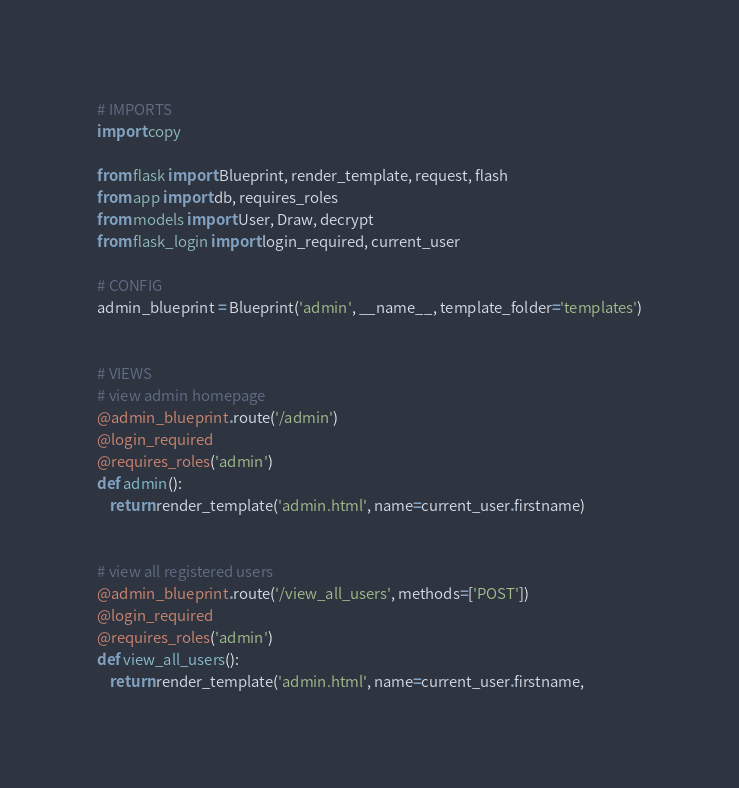Convert code to text. <code><loc_0><loc_0><loc_500><loc_500><_Python_># IMPORTS
import copy

from flask import Blueprint, render_template, request, flash
from app import db, requires_roles
from models import User, Draw, decrypt
from flask_login import login_required, current_user

# CONFIG
admin_blueprint = Blueprint('admin', __name__, template_folder='templates')


# VIEWS
# view admin homepage
@admin_blueprint.route('/admin')
@login_required
@requires_roles('admin')
def admin():
    return render_template('admin.html', name=current_user.firstname)


# view all registered users
@admin_blueprint.route('/view_all_users', methods=['POST'])
@login_required
@requires_roles('admin')
def view_all_users():
    return render_template('admin.html', name=current_user.firstname,</code> 